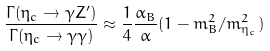<formula> <loc_0><loc_0><loc_500><loc_500>\frac { \Gamma ( \eta _ { c } \rightarrow \gamma Z ^ { \prime } ) } { \Gamma ( \eta _ { c } \rightarrow \gamma \gamma ) } \approx \frac { 1 } { 4 } \frac { \alpha _ { B } } { \alpha } ( 1 - m _ { B } ^ { 2 } / m _ { \eta _ { c } } ^ { 2 } )</formula> 